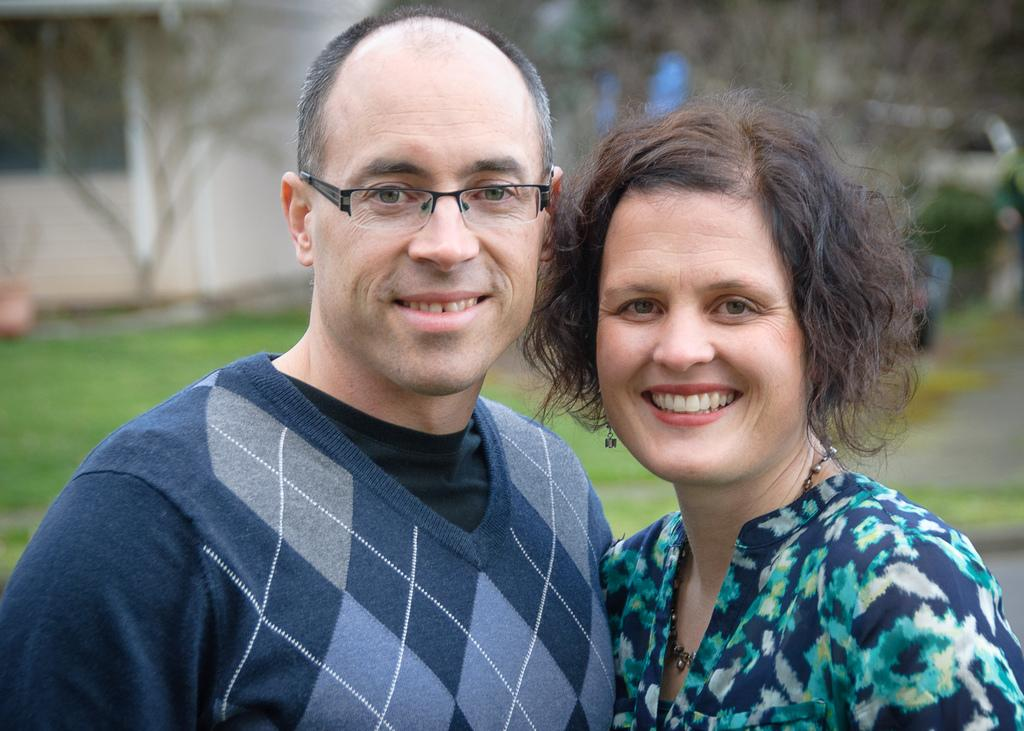How many people are present in the image? There are two people, a woman and a man, present in the image. What expressions do the people in the image have? Both the woman and the man are smiling in the image. What can be seen in the background of the image? There are cars, trees, and a building visible in the background of the image. What type of vegetation is on the left side of the image? There is grass on the left side of the image. What story is the woman telling the giant in the image? There are no giants present in the image, and the woman is not telling a story to anyone. 